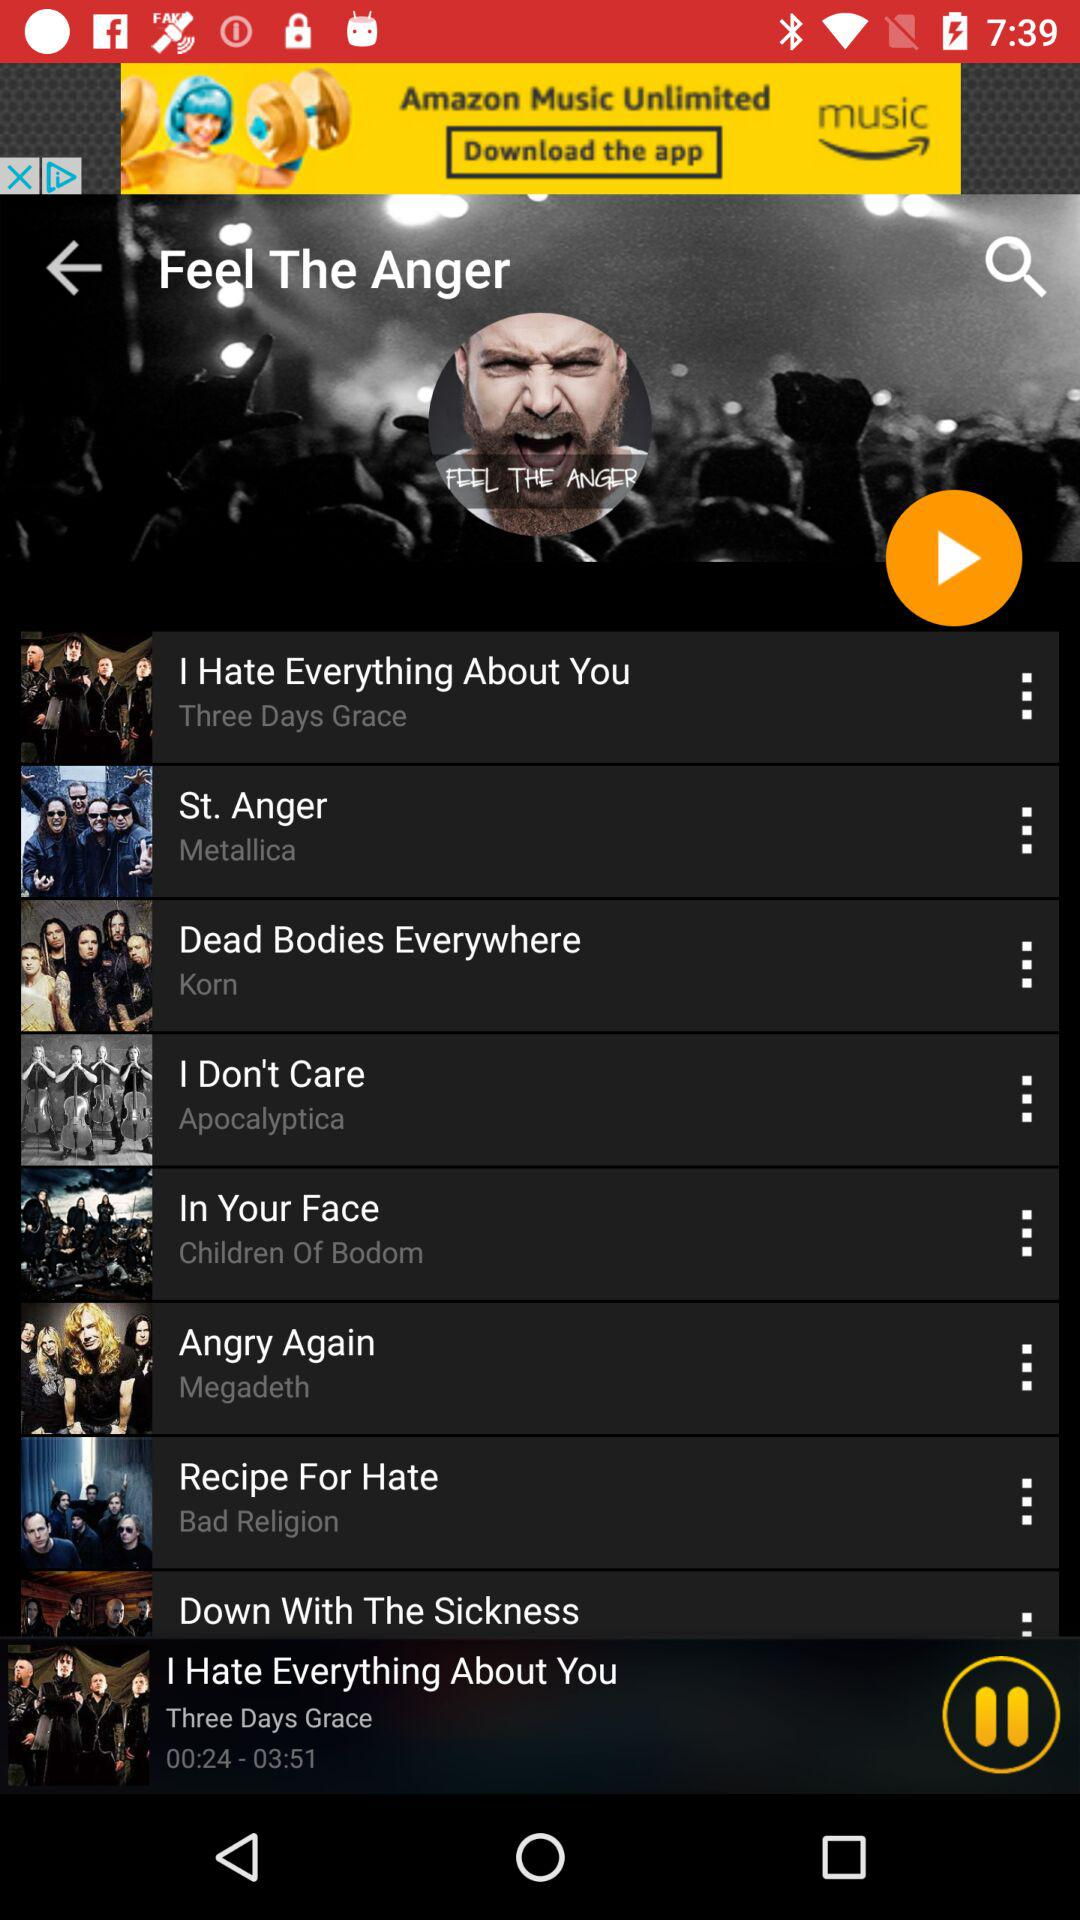What is the album name of the song "I Hate Everything About You"? The album's name is "Three Days Grace". 